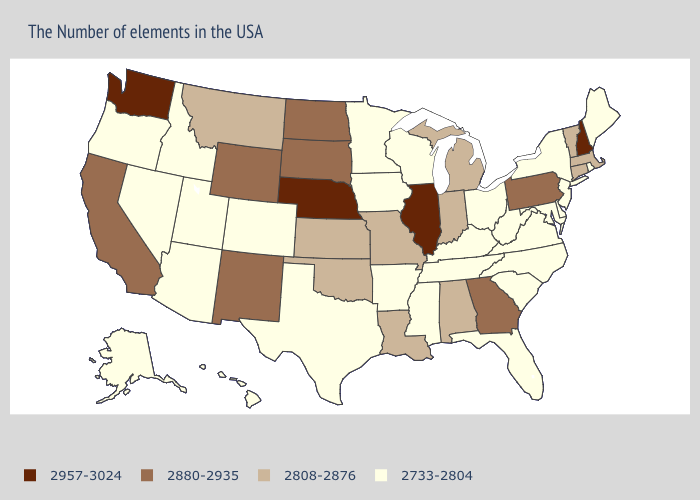What is the lowest value in states that border Kansas?
Quick response, please. 2733-2804. Name the states that have a value in the range 2733-2804?
Give a very brief answer. Maine, Rhode Island, New York, New Jersey, Delaware, Maryland, Virginia, North Carolina, South Carolina, West Virginia, Ohio, Florida, Kentucky, Tennessee, Wisconsin, Mississippi, Arkansas, Minnesota, Iowa, Texas, Colorado, Utah, Arizona, Idaho, Nevada, Oregon, Alaska, Hawaii. What is the highest value in the USA?
Concise answer only. 2957-3024. What is the value of Virginia?
Short answer required. 2733-2804. What is the value of Virginia?
Short answer required. 2733-2804. What is the value of Arkansas?
Write a very short answer. 2733-2804. Name the states that have a value in the range 2957-3024?
Keep it brief. New Hampshire, Illinois, Nebraska, Washington. Which states have the lowest value in the West?
Give a very brief answer. Colorado, Utah, Arizona, Idaho, Nevada, Oregon, Alaska, Hawaii. What is the value of Utah?
Short answer required. 2733-2804. Does Hawaii have the lowest value in the USA?
Write a very short answer. Yes. Which states hav the highest value in the MidWest?
Concise answer only. Illinois, Nebraska. Which states have the lowest value in the Northeast?
Quick response, please. Maine, Rhode Island, New York, New Jersey. Among the states that border South Dakota , which have the lowest value?
Quick response, please. Minnesota, Iowa. Does Kansas have a higher value than Illinois?
Concise answer only. No. Does Utah have the lowest value in the USA?
Give a very brief answer. Yes. 